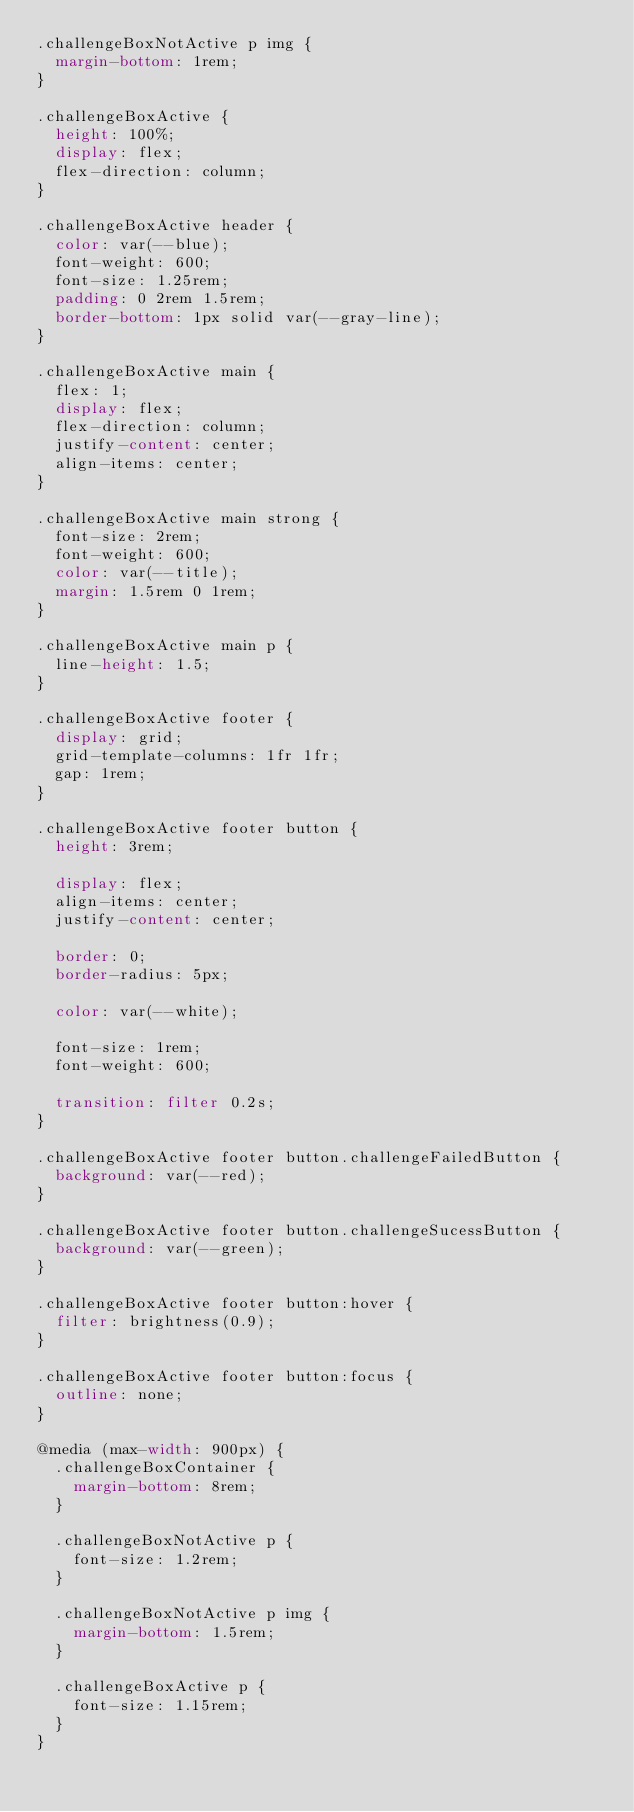<code> <loc_0><loc_0><loc_500><loc_500><_CSS_>.challengeBoxNotActive p img {
  margin-bottom: 1rem;
}

.challengeBoxActive {
  height: 100%;
  display: flex;
  flex-direction: column;
}

.challengeBoxActive header {
  color: var(--blue);
  font-weight: 600;
  font-size: 1.25rem;
  padding: 0 2rem 1.5rem;
  border-bottom: 1px solid var(--gray-line);
}

.challengeBoxActive main {
  flex: 1;
  display: flex;
  flex-direction: column;
  justify-content: center;
  align-items: center;
}

.challengeBoxActive main strong {
  font-size: 2rem;
  font-weight: 600;
  color: var(--title);
  margin: 1.5rem 0 1rem;
}

.challengeBoxActive main p {
  line-height: 1.5;
}

.challengeBoxActive footer {
  display: grid;
  grid-template-columns: 1fr 1fr;
  gap: 1rem;
}

.challengeBoxActive footer button {
  height: 3rem;

  display: flex;
  align-items: center;
  justify-content: center;

  border: 0;
  border-radius: 5px;

  color: var(--white);

  font-size: 1rem;
  font-weight: 600;

  transition: filter 0.2s;
}

.challengeBoxActive footer button.challengeFailedButton {
  background: var(--red);
}

.challengeBoxActive footer button.challengeSucessButton {
  background: var(--green);
}

.challengeBoxActive footer button:hover {
  filter: brightness(0.9);
}

.challengeBoxActive footer button:focus {
  outline: none;
}

@media (max-width: 900px) {
  .challengeBoxContainer {
    margin-bottom: 8rem;
  }

  .challengeBoxNotActive p {
    font-size: 1.2rem;
  }

  .challengeBoxNotActive p img {
    margin-bottom: 1.5rem;
  }

  .challengeBoxActive p {
    font-size: 1.15rem;
  }
}
</code> 